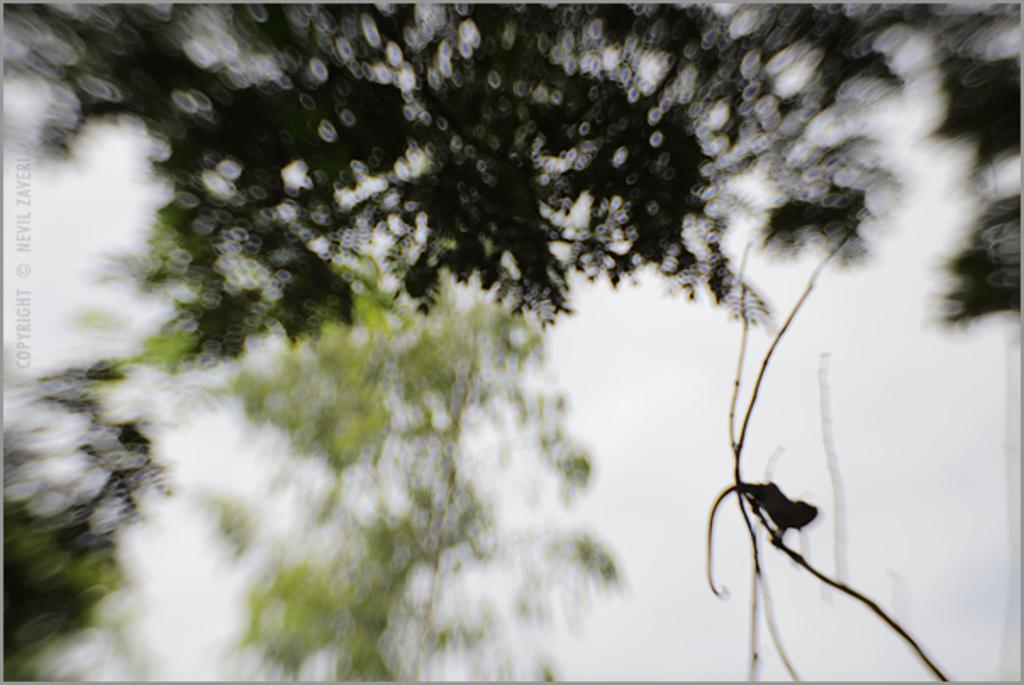What type of animal is on a stem in the image? There is a reptile on a stem in the image. Where is the reptile located in the image? The reptile is on the right side of the image. What type of vegetation can be seen in the image? There are trees visible in the image. What part of the natural environment is visible in the image? The sky is visible in the image, although it is blurred. What is present on the left side of the image? There is text on the left side of the image. What type of cough medicine is advertised on the left side of the image? There is no cough medicine or advertisement present in the image; it features a reptile on a stem, trees, and text. 